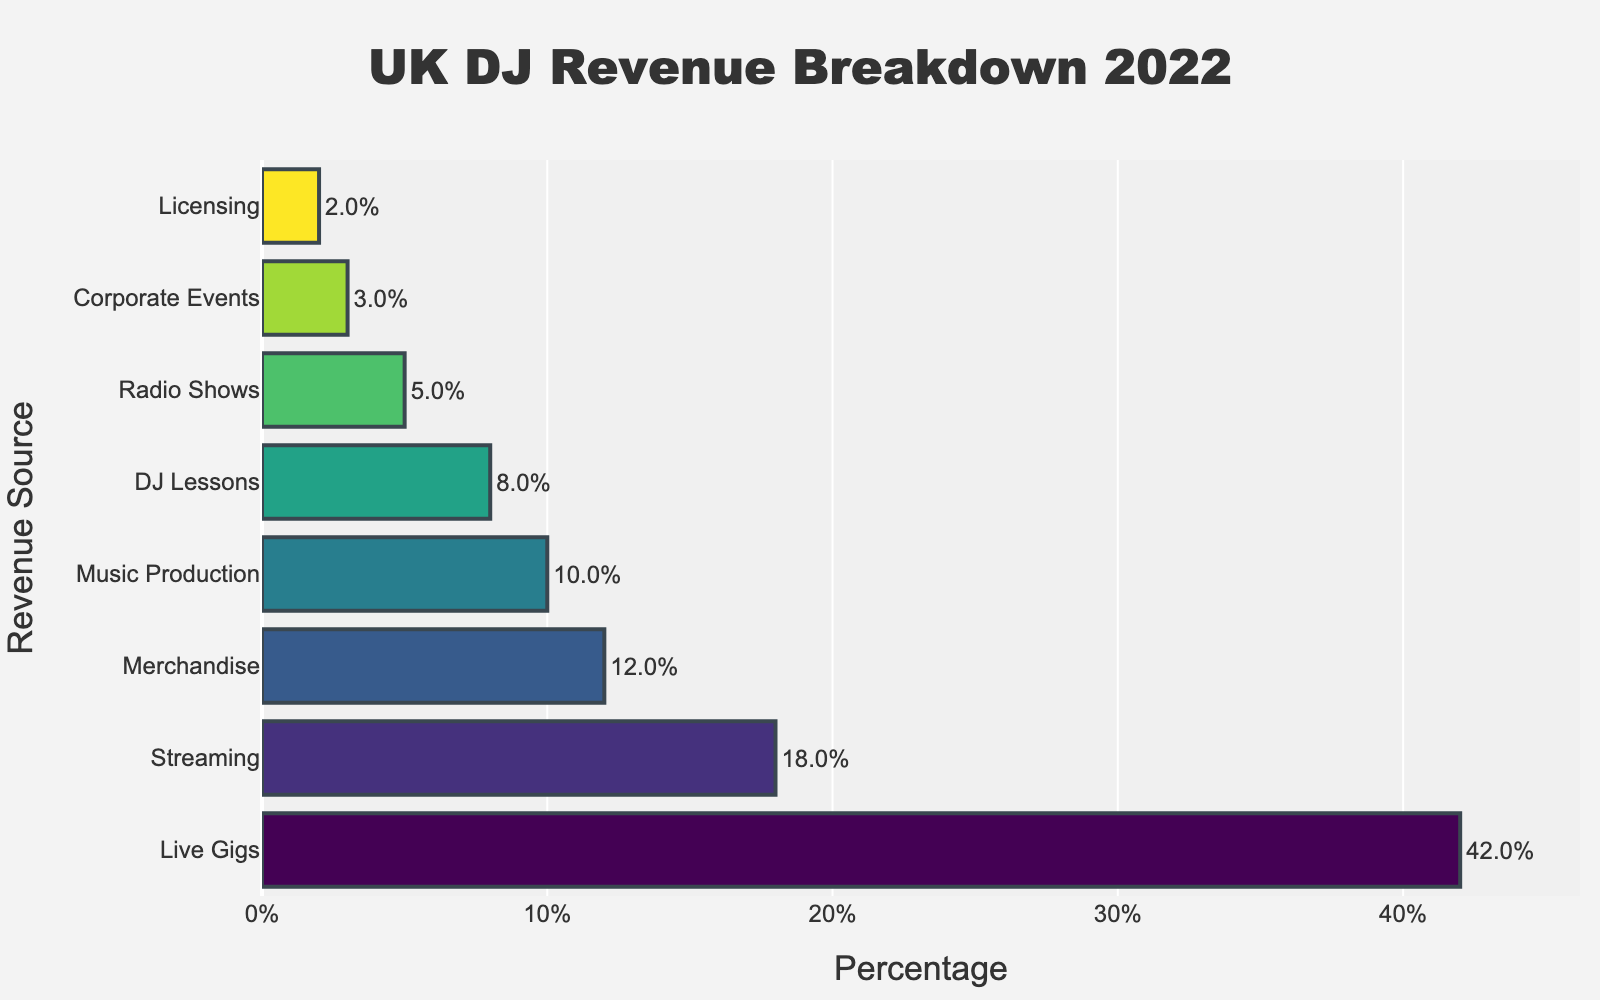Which revenue source has the highest percentage? The bar chart shows different revenue sources for professional DJs by percentage. The longest bar represents the revenue source with the highest percentage.
Answer: Live Gigs What is the combined percentage of Streaming, Merchandise, and DJ Lessons? Referring to the values on the horizontal axis of the bars for Streaming (18%), Merchandise (12%), and DJ Lessons (8%), and then adding these percentages together: 18% + 12% + 8% = 38%.
Answer: 38% Which revenue source brings in more revenue, Music Production or Merchandise? Compare the lengths of the bars for Music Production and Merchandise. Merchandise has a percentage of 12%, while Music Production has a percentage of 10%.
Answer: Merchandise How much greater is the percentage of Live Gigs compared to Radio Shows? Subtract the percentage value of Radio Shows (5%) from the percentage value of Live Gigs (42%): 42% - 5% = 37%.
Answer: 37% What percentage of revenue comes from Corporate Events and Licensing combined? Referring to the values on the horizontal axis of the bars for Corporate Events (3%) and Licensing (2%), and then adding these percentages together: 3% + 2% = 5%.
Answer: 5% Which revenue source has the smallest contribution? Look for the bar with the shortest length. The bar for Licensing shows a percentage of 2%, which is the smallest.
Answer: Licensing What is the average percentage for Merchandise, Music Production, and DJ Lessons? Adding the percentage values for Merchandise (12%), Music Production (10%), and DJ Lessons (8%) and then dividing by 3: (12% + 10% + 8%) / 3 = 10%.
Answer: 10% Is the percentage from Radio Shows greater than the percentage from Corporate Events? Comparing the lengths of the bars, Radio Shows have a percentage of 5%, while Corporate Events have a percentage of 3%. 5% is greater than 3%.
Answer: Yes What is the difference in percentage between Streaming and Radio Shows? Subtract the percentage value of Radio Shows (5%) from the percentage value of Streaming (18%): 18% - 5% = 13%.
Answer: 13% 